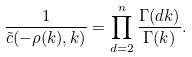<formula> <loc_0><loc_0><loc_500><loc_500>\frac { 1 } { \tilde { c } ( - \rho ( k ) , k ) } = \prod _ { d = 2 } ^ { n } \frac { \Gamma ( d k ) } { \Gamma ( k ) } .</formula> 